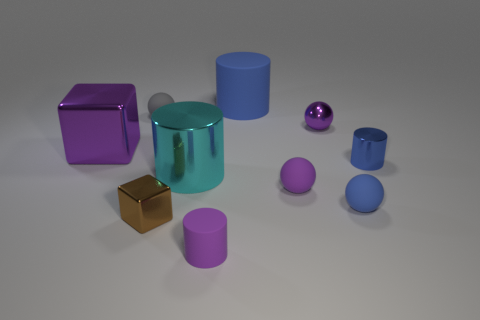Subtract all shiny balls. How many balls are left? 3 Subtract all brown cubes. How many cubes are left? 1 Subtract 1 spheres. How many spheres are left? 3 Subtract all spheres. How many objects are left? 6 Subtract all blue cylinders. Subtract all purple cubes. How many cylinders are left? 2 Add 5 tiny shiny cylinders. How many tiny shiny cylinders are left? 6 Add 7 blue matte objects. How many blue matte objects exist? 9 Subtract 0 green spheres. How many objects are left? 10 Subtract all purple cubes. How many purple balls are left? 2 Subtract all gray matte objects. Subtract all tiny brown cubes. How many objects are left? 8 